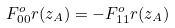<formula> <loc_0><loc_0><loc_500><loc_500>F _ { 0 0 } ^ { o } r ( z _ { A } ) = - F _ { 1 1 } ^ { o } r ( z _ { A } )</formula> 